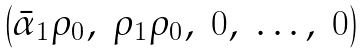<formula> <loc_0><loc_0><loc_500><loc_500>\begin{pmatrix} \bar { \alpha } _ { 1 } \rho _ { 0 } , & \rho _ { 1 } \rho _ { 0 } , & 0 , & \dots , & 0 \end{pmatrix}</formula> 